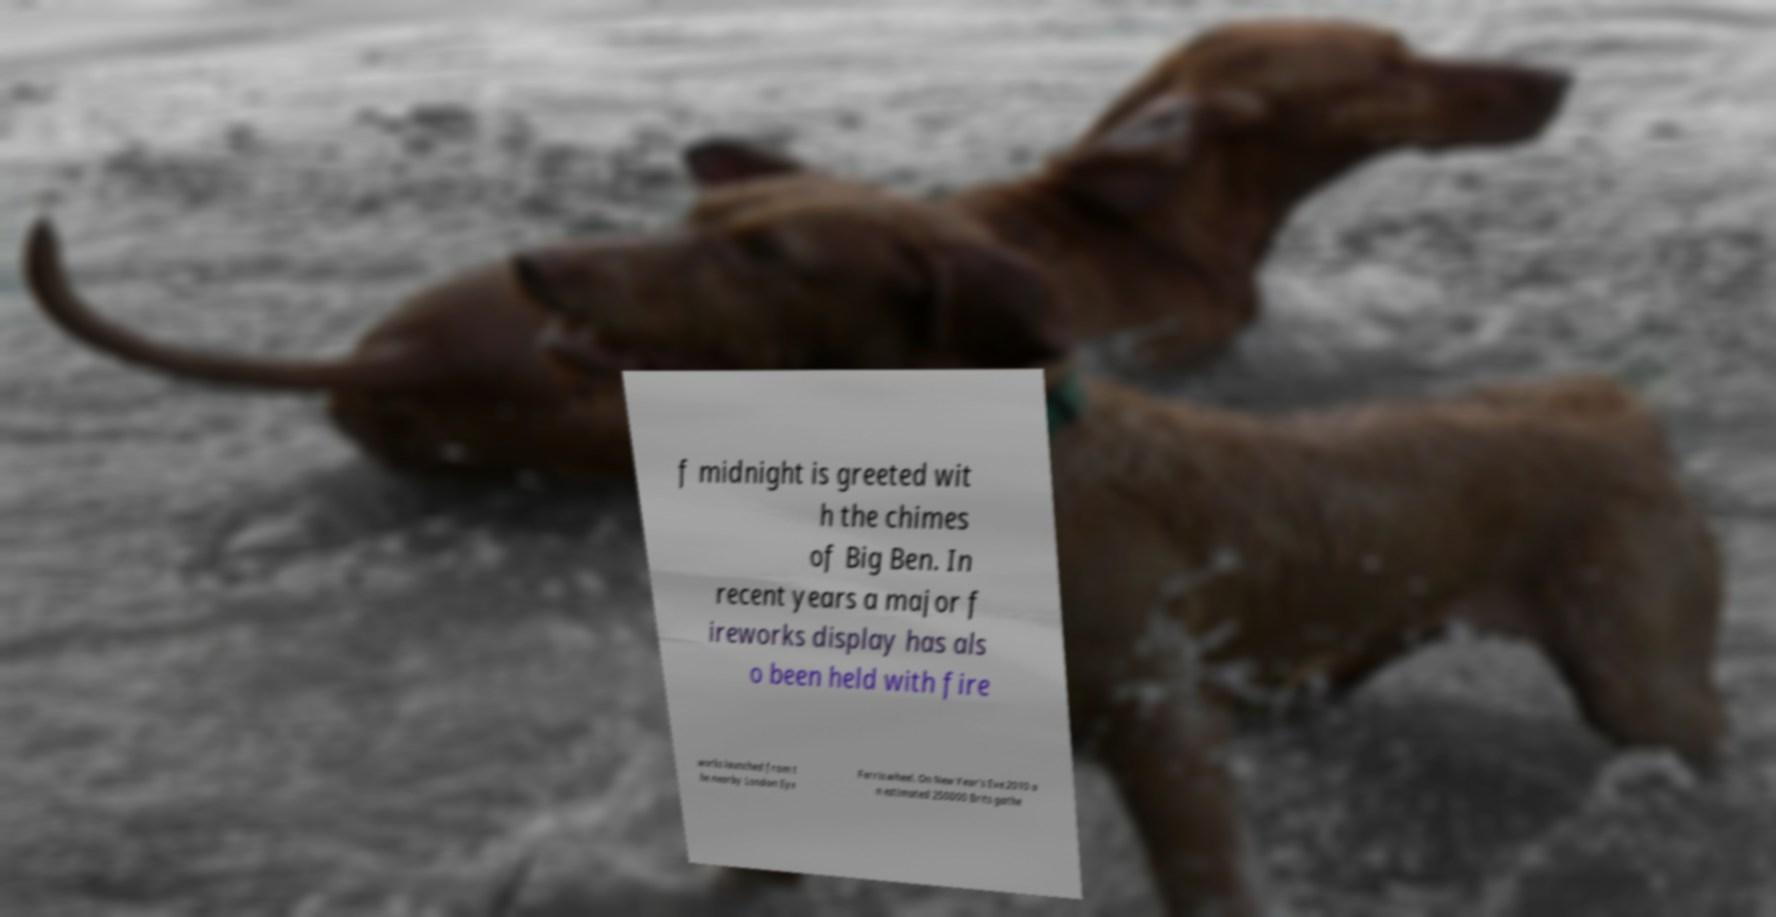Can you accurately transcribe the text from the provided image for me? f midnight is greeted wit h the chimes of Big Ben. In recent years a major f ireworks display has als o been held with fire works launched from t he nearby London Eye Ferris wheel. On New Year's Eve 2010 a n estimated 250000 Brits gathe 